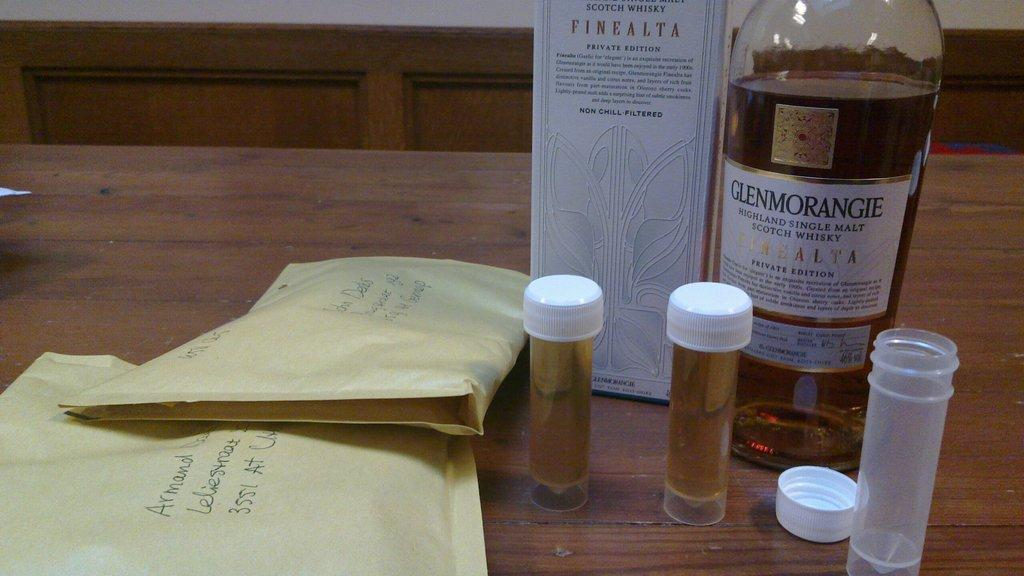Provide a one-sentence caption for the provided image. A bottle of Glenmorangie single malt scotch whisky is on a table along with several vials and two envelopes. 